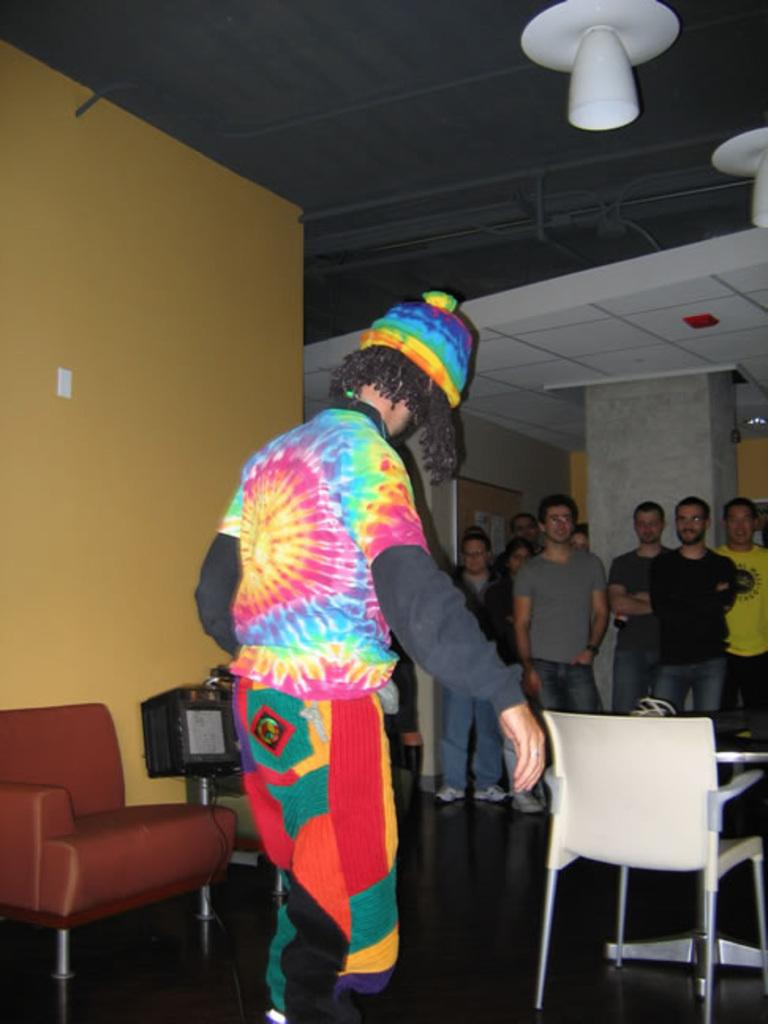What color is the wall that can be seen in the image? The wall in the image is yellow. What else can be seen in the image besides the wall? There are people standing in the image, as well as a sofa and a chair. How many cars are parked on the hook in the image? There are no cars or hooks present in the image. What type of bubble can be seen floating near the people in the image? There are no bubbles present in the image. 